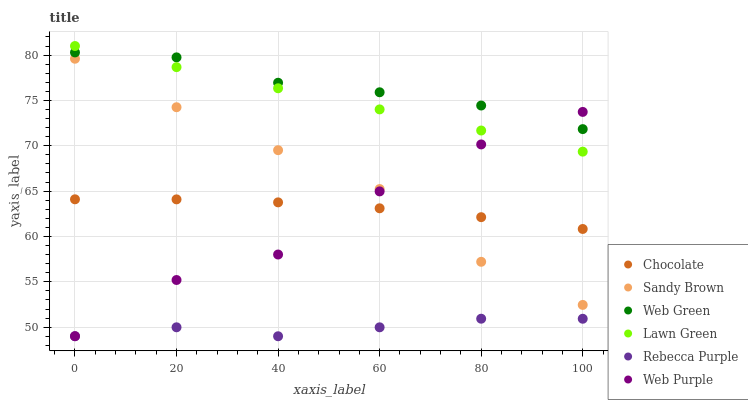Does Rebecca Purple have the minimum area under the curve?
Answer yes or no. Yes. Does Web Green have the maximum area under the curve?
Answer yes or no. Yes. Does Chocolate have the minimum area under the curve?
Answer yes or no. No. Does Chocolate have the maximum area under the curve?
Answer yes or no. No. Is Lawn Green the smoothest?
Answer yes or no. Yes. Is Web Purple the roughest?
Answer yes or no. Yes. Is Web Green the smoothest?
Answer yes or no. No. Is Web Green the roughest?
Answer yes or no. No. Does Rebecca Purple have the lowest value?
Answer yes or no. Yes. Does Chocolate have the lowest value?
Answer yes or no. No. Does Lawn Green have the highest value?
Answer yes or no. Yes. Does Web Green have the highest value?
Answer yes or no. No. Is Sandy Brown less than Lawn Green?
Answer yes or no. Yes. Is Lawn Green greater than Rebecca Purple?
Answer yes or no. Yes. Does Sandy Brown intersect Web Purple?
Answer yes or no. Yes. Is Sandy Brown less than Web Purple?
Answer yes or no. No. Is Sandy Brown greater than Web Purple?
Answer yes or no. No. Does Sandy Brown intersect Lawn Green?
Answer yes or no. No. 